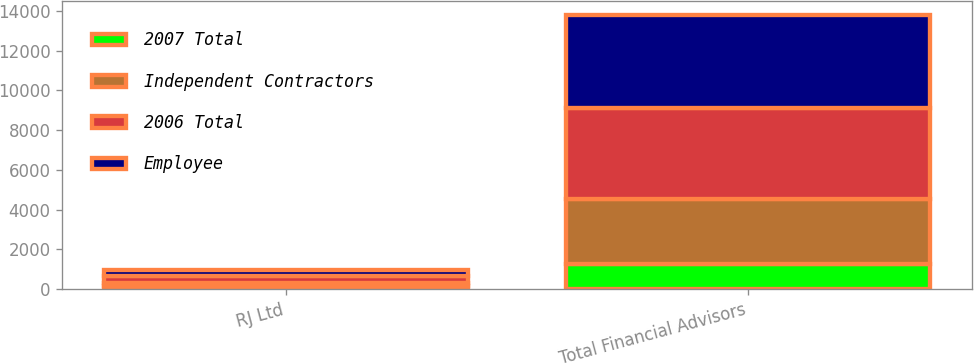Convert chart. <chart><loc_0><loc_0><loc_500><loc_500><stacked_bar_chart><ecel><fcel>RJ Ltd<fcel>Total Financial Advisors<nl><fcel>2007 Total<fcel>186<fcel>1273<nl><fcel>Independent Contractors<fcel>139<fcel>3288<nl><fcel>2006 Total<fcel>325<fcel>4561<nl><fcel>Employee<fcel>312<fcel>4665<nl></chart> 